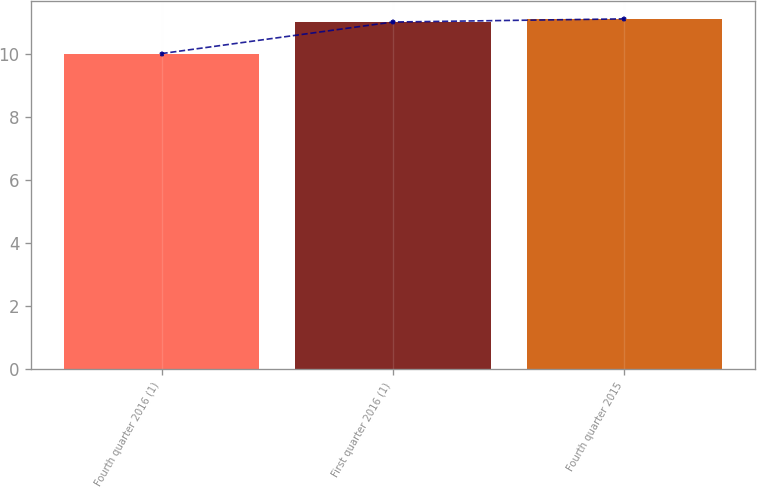<chart> <loc_0><loc_0><loc_500><loc_500><bar_chart><fcel>Fourth quarter 2016 (1)<fcel>First quarter 2016 (1)<fcel>Fourth quarter 2015<nl><fcel>10<fcel>11<fcel>11.1<nl></chart> 